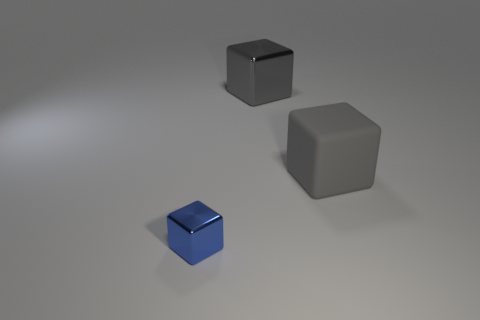Does the metal cube that is right of the blue metallic thing have the same size as the rubber object?
Your answer should be very brief. Yes. There is a big gray object that is right of the big gray metallic block that is behind the large object that is in front of the large metal block; what is it made of?
Provide a succinct answer. Rubber. There is a metallic block that is behind the tiny metallic block; is it the same color as the thing that is on the right side of the gray metal thing?
Give a very brief answer. Yes. The gray thing that is to the right of the metallic block that is behind the tiny blue metallic block is made of what material?
Give a very brief answer. Rubber. The metal cube that is the same size as the rubber cube is what color?
Offer a terse response. Gray. What is the shape of the metallic thing that is the same color as the rubber object?
Your answer should be very brief. Cube. What number of large metal things are right of the large thing that is to the right of the shiny cube on the right side of the blue cube?
Make the answer very short. 0. What size is the shiny object that is to the right of the metal thing that is in front of the gray metallic block?
Your answer should be compact. Large. The other cube that is made of the same material as the blue block is what size?
Your answer should be compact. Large. What is the shape of the thing that is in front of the large shiny cube and to the right of the blue metal cube?
Provide a succinct answer. Cube. 